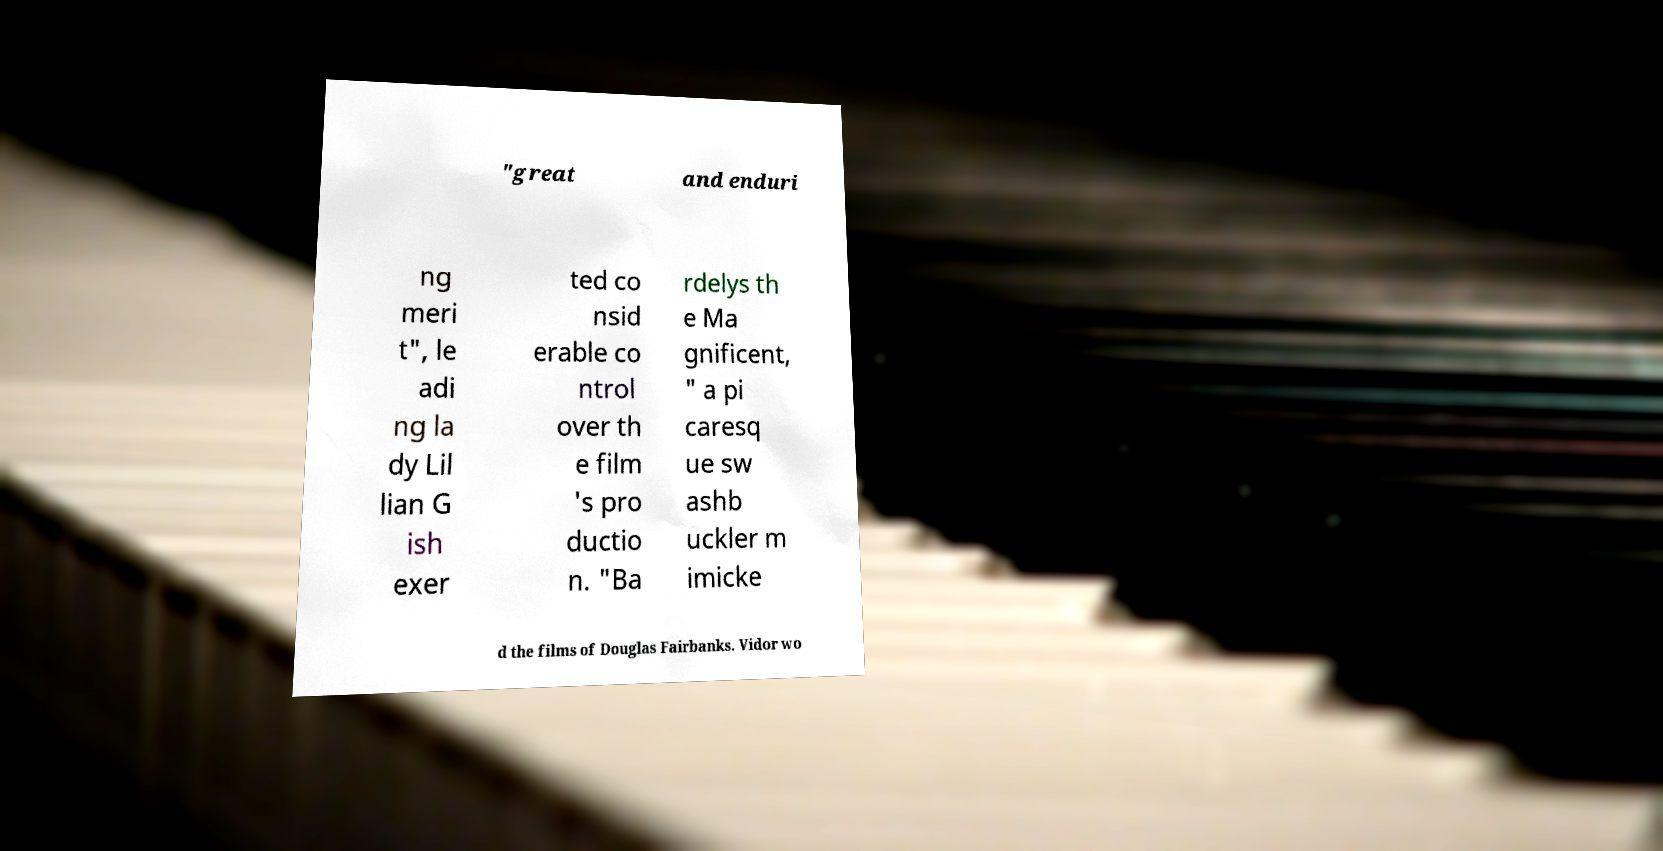Can you read and provide the text displayed in the image?This photo seems to have some interesting text. Can you extract and type it out for me? "great and enduri ng meri t", le adi ng la dy Lil lian G ish exer ted co nsid erable co ntrol over th e film 's pro ductio n. "Ba rdelys th e Ma gnificent, " a pi caresq ue sw ashb uckler m imicke d the films of Douglas Fairbanks. Vidor wo 